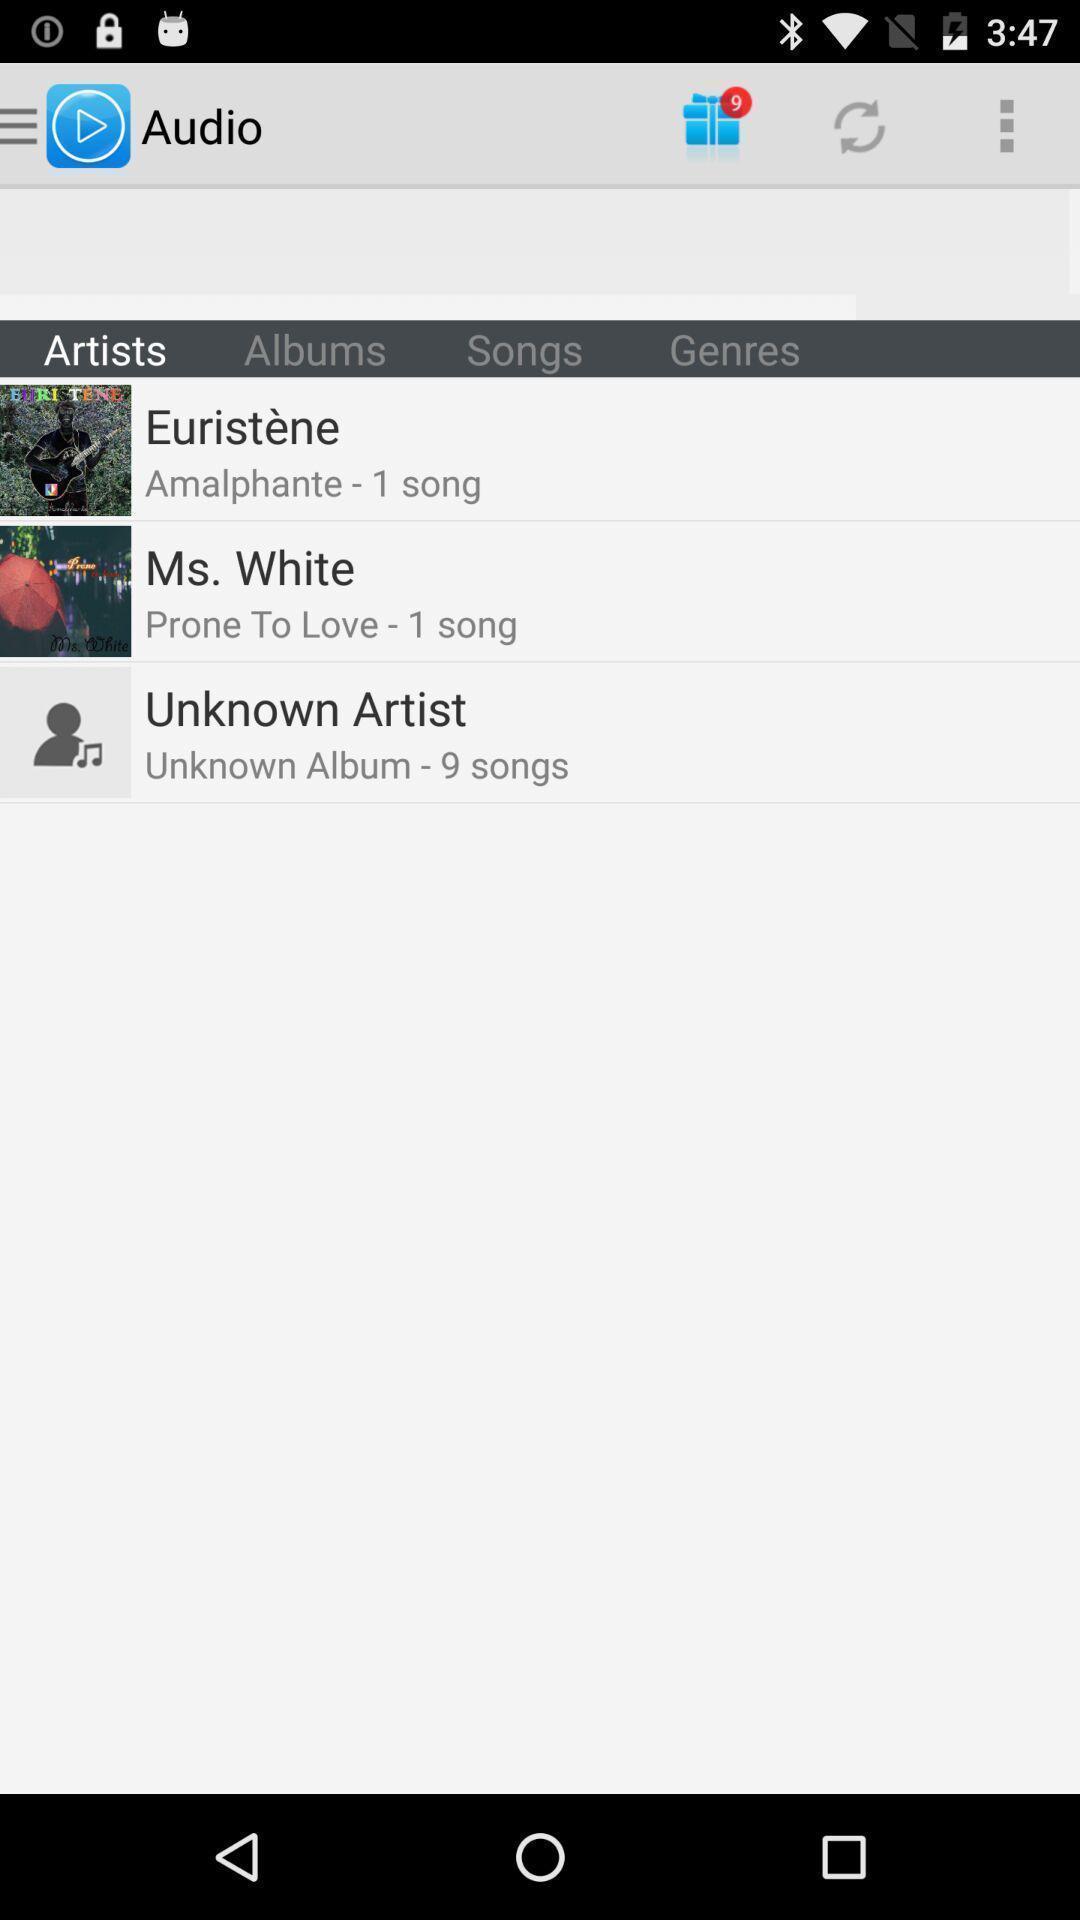Explain what's happening in this screen capture. Screen displaying list of songs in an audio application. 